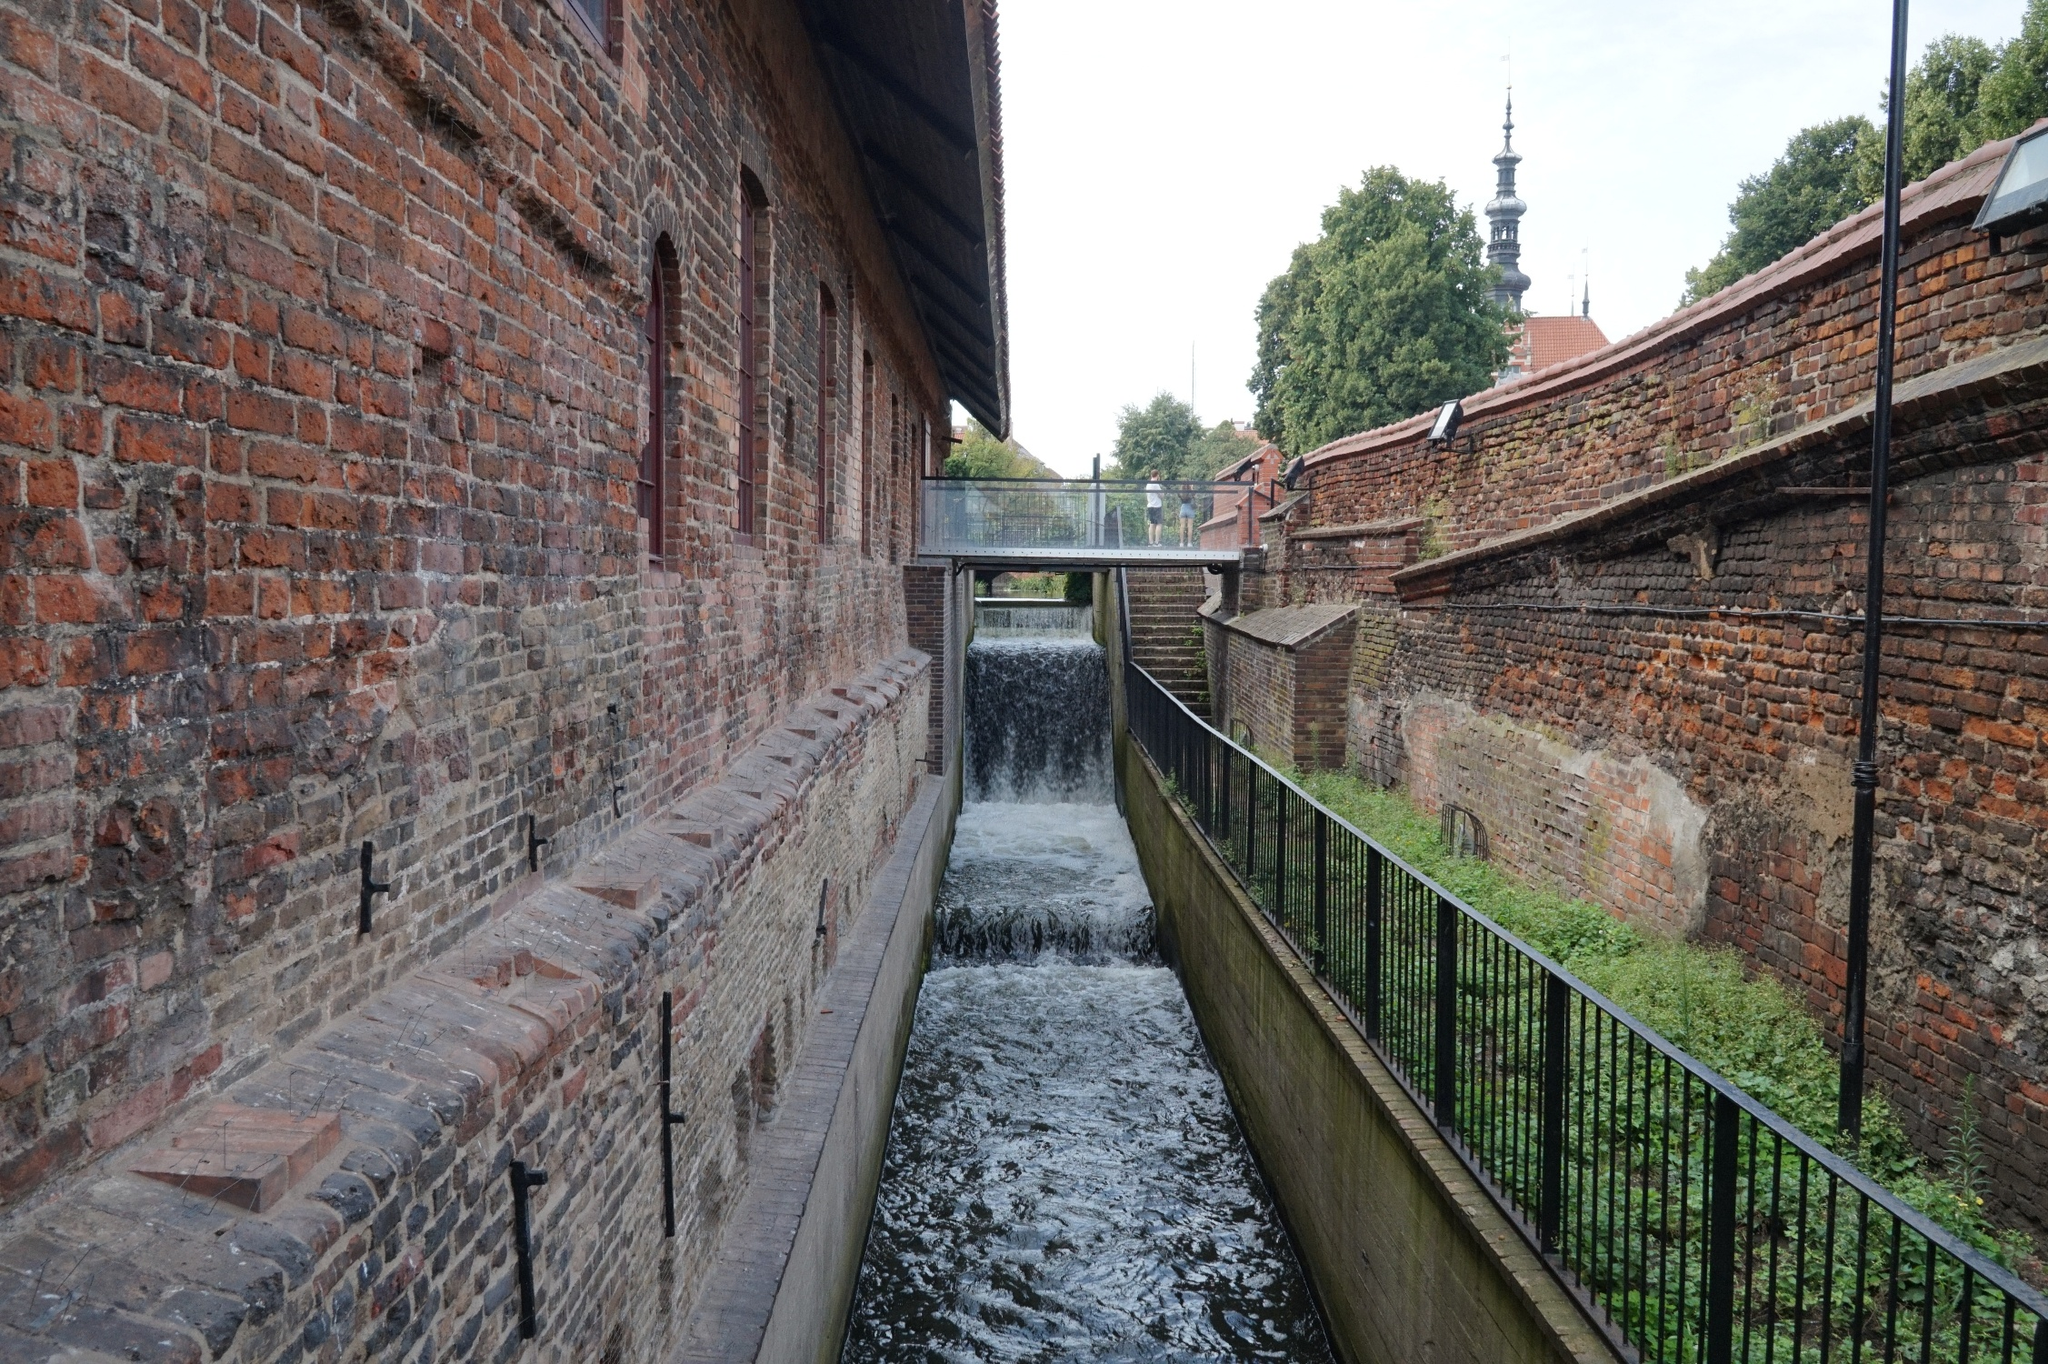What might someone be doing here on a typical day? On a typical day, people might be using the walkway as a scenic shortcut through the town. A young woman jogs along the path, her pace steady and rhythmic. An elderly man sits on a bench nearby, feeding the birds and reminiscing about the changes he’s seen over the years. Schoolchildren, accompanied by their teacher, are on a field trip learning about the historical significance of the canal and the old building beside it. The setting is peacefully bustling, with everyone going about their daily routines under the watchful gaze of the towering church spire. 